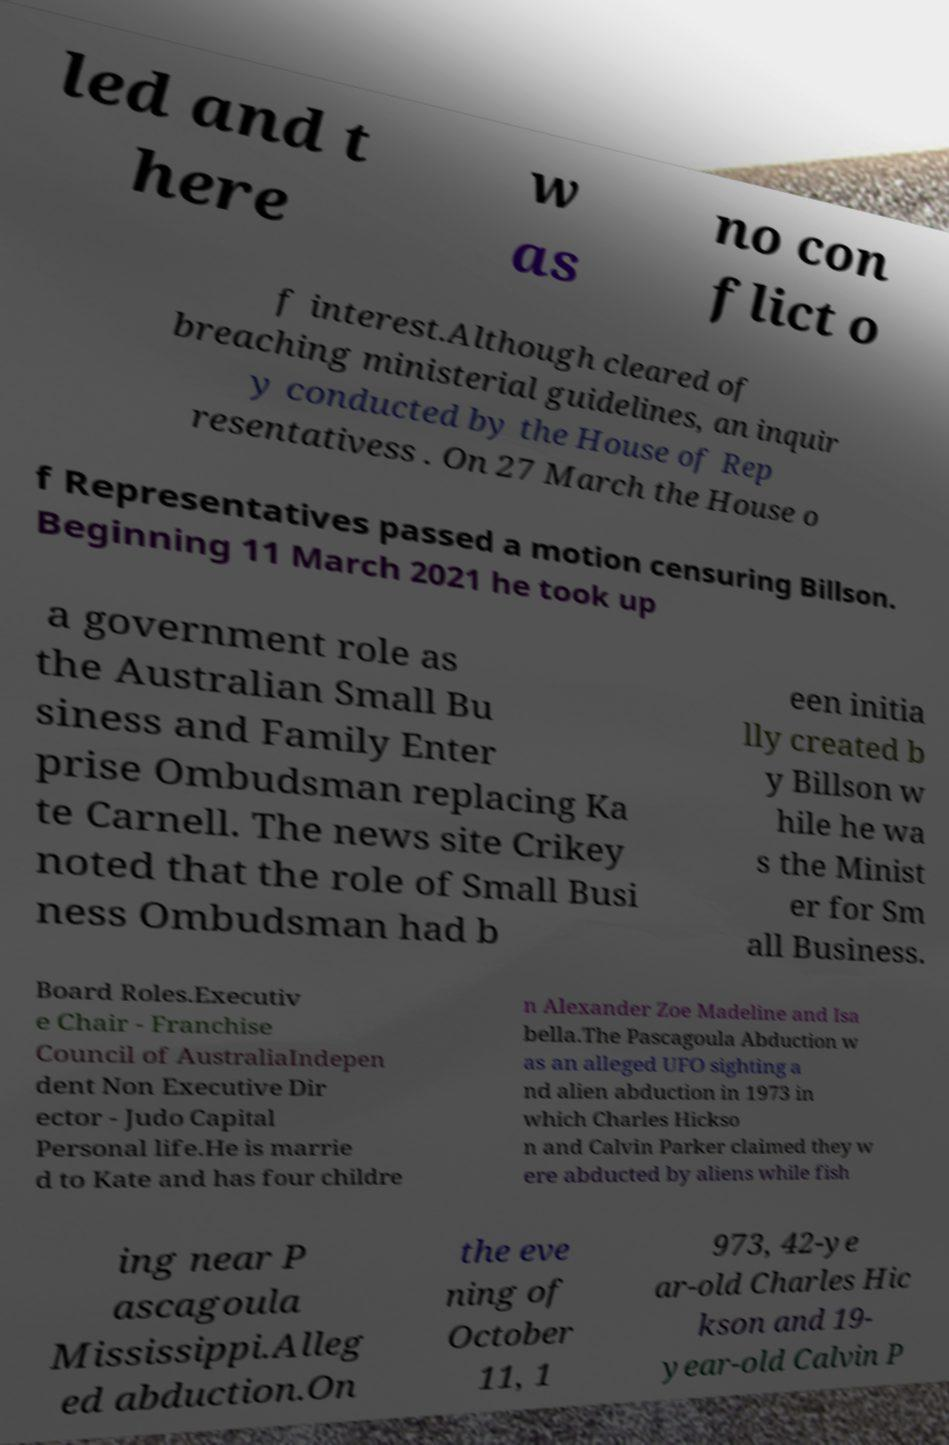There's text embedded in this image that I need extracted. Can you transcribe it verbatim? led and t here w as no con flict o f interest.Although cleared of breaching ministerial guidelines, an inquir y conducted by the House of Rep resentativess . On 27 March the House o f Representatives passed a motion censuring Billson. Beginning 11 March 2021 he took up a government role as the Australian Small Bu siness and Family Enter prise Ombudsman replacing Ka te Carnell. The news site Crikey noted that the role of Small Busi ness Ombudsman had b een initia lly created b y Billson w hile he wa s the Minist er for Sm all Business. Board Roles.Executiv e Chair - Franchise Council of AustraliaIndepen dent Non Executive Dir ector - Judo Capital Personal life.He is marrie d to Kate and has four childre n Alexander Zoe Madeline and Isa bella.The Pascagoula Abduction w as an alleged UFO sighting a nd alien abduction in 1973 in which Charles Hickso n and Calvin Parker claimed they w ere abducted by aliens while fish ing near P ascagoula Mississippi.Alleg ed abduction.On the eve ning of October 11, 1 973, 42-ye ar-old Charles Hic kson and 19- year-old Calvin P 